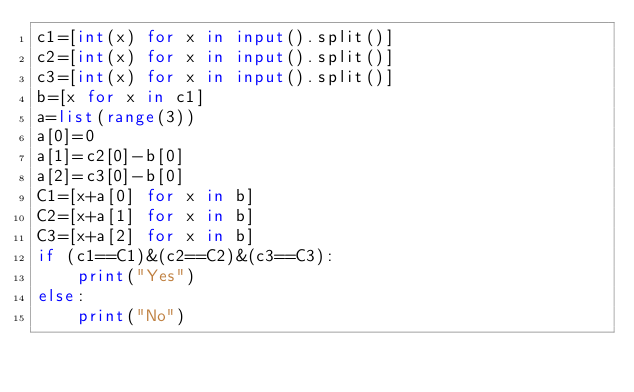<code> <loc_0><loc_0><loc_500><loc_500><_Python_>c1=[int(x) for x in input().split()]
c2=[int(x) for x in input().split()]
c3=[int(x) for x in input().split()]
b=[x for x in c1]
a=list(range(3))
a[0]=0
a[1]=c2[0]-b[0]
a[2]=c3[0]-b[0]
C1=[x+a[0] for x in b]
C2=[x+a[1] for x in b]
C3=[x+a[2] for x in b]
if (c1==C1)&(c2==C2)&(c3==C3):
	print("Yes")
else:
	print("No")
</code> 